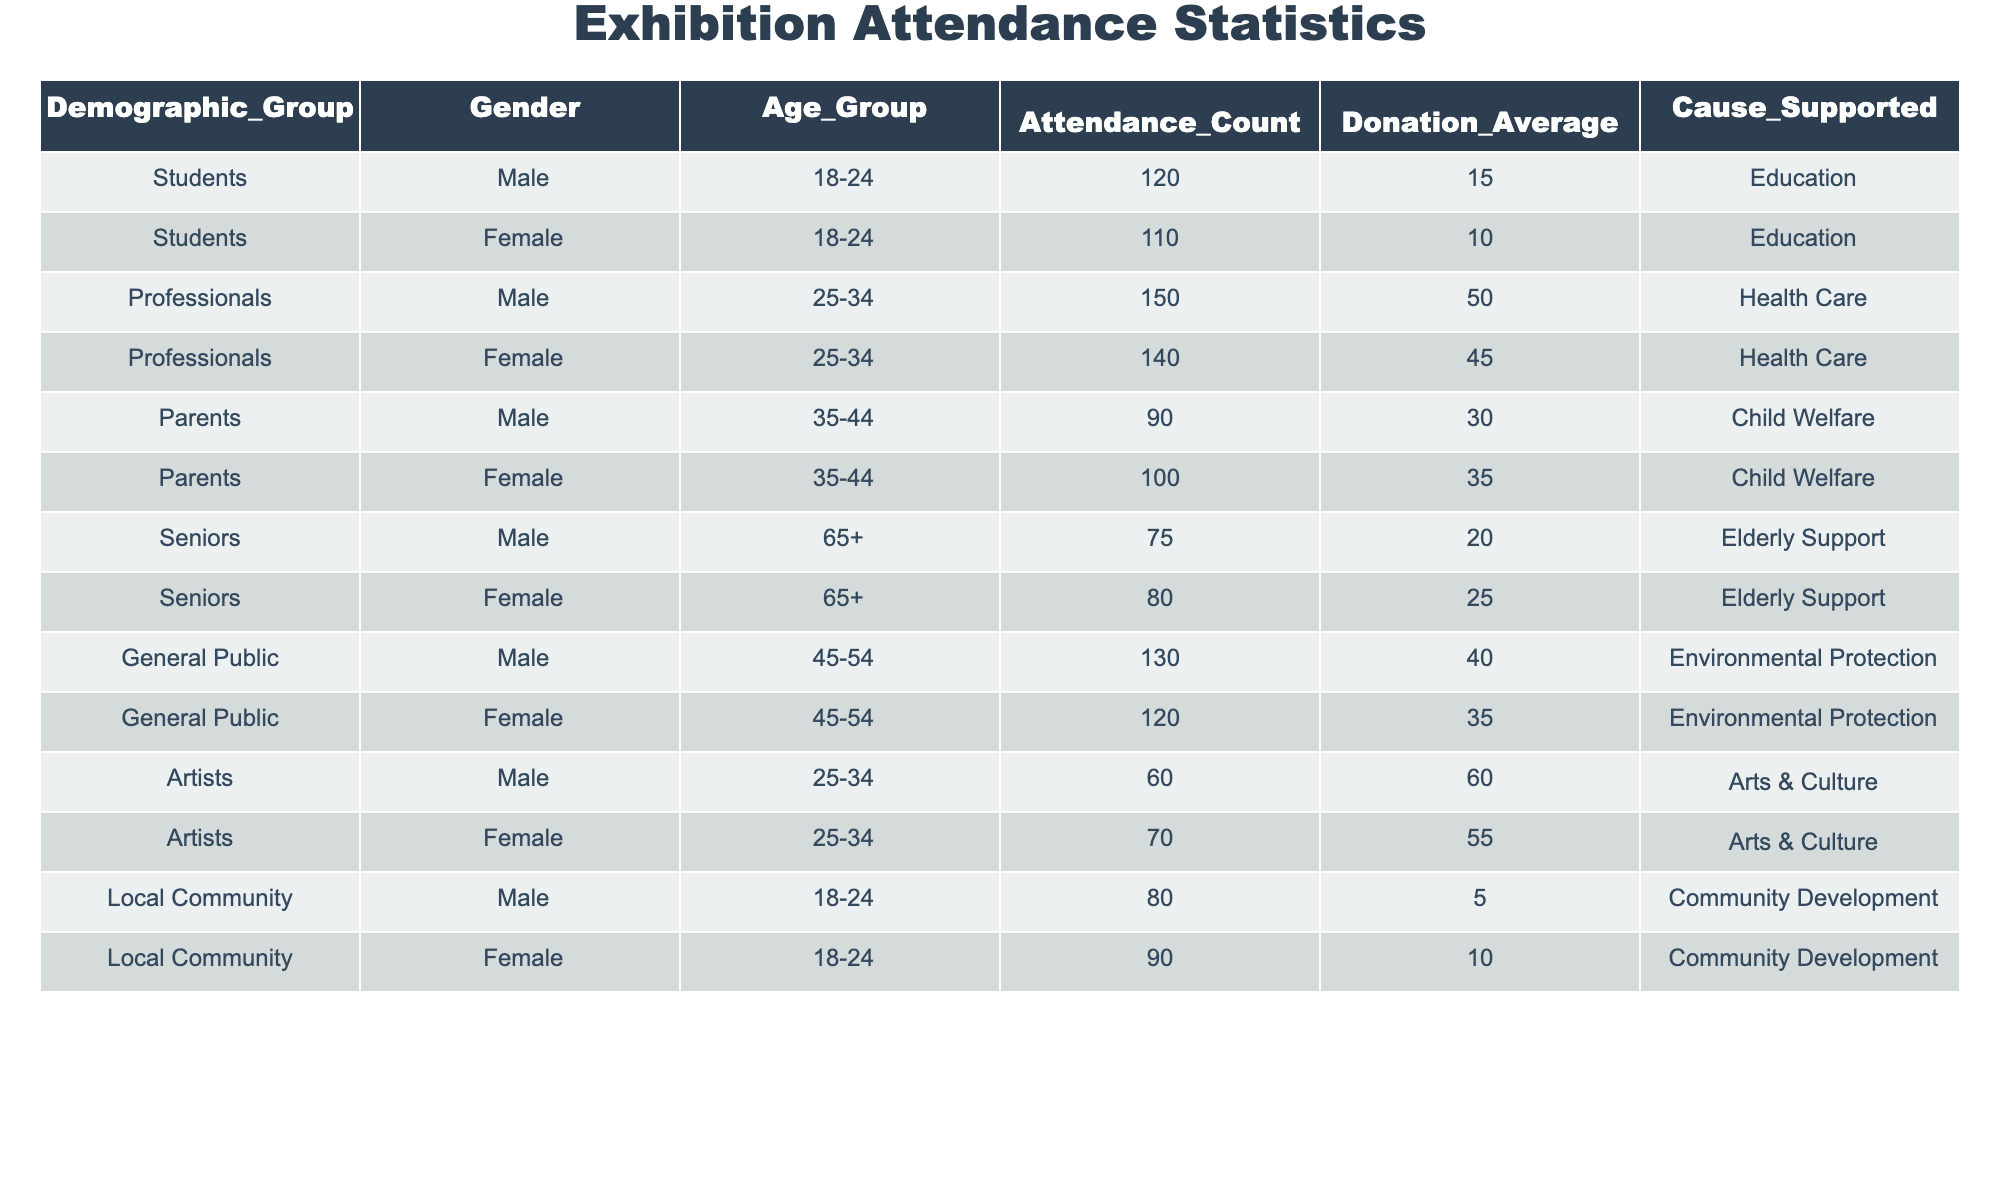What is the attendance count for Female attendees aged 25-34? From the table, the attendance count for Female attendees in the 25-34 age group is directly listed as 140.
Answer: 140 What is the average donation amount for Male Seniors (65+)? The average donation amount for Male Seniors is listed as 20 in the table.
Answer: 20 Which demographic group has the highest total attendance? To find the total attendance, we sum the attendance counts for each demographic group: Students (230), Professionals (290), Parents (190), Seniors (155), General Public (250), Artists (130), Local Community (170); Professionals have the highest total attendance of 290.
Answer: Professionals Is the average donation for Female Students higher than that for Female Parents? The average donation for Female Students is 10, and for Female Parents, it is 35. Since 10 is not greater than 35, the answer is no.
Answer: No What is the difference in average donations between Male Professionals and Male Artists? The average donation for Male Professionals is 50 and for Male Artists is 60. The difference is calculated as 60 - 50 = 10.
Answer: 10 Which demographic group supported Elderly Support with the highest average donation? For the Elderly Support cause, the average donation amounts from Male Seniors is 20 and Female Seniors is 25. Since 25 is higher, Female Seniors have the highest average donation.
Answer: Female Seniors How many total Male attendees are there across all age groups? We sum the attendance counts for all Male attendees: 120 (Students) + 150 (Professionals) + 90 (Parents) + 75 (Seniors) + 130 (General Public) + 60 (Artists) + 80 (Local Community) = 705.
Answer: 705 Do Male and Female Seniors have the same average donation amount? The average donation for Male Seniors is 20 and for Female Seniors is 25. Since these amounts are different, the answer is no.
Answer: No What is the total attendance for all groups under the age group of 18-24? The total attendance for age group 18-24 consists of Male Students (120) + Female Students (110) + Male Local Community (80) + Female Local Community (90) = 400.
Answer: 400 Which demographic group's attendees supported Education cause the most? The total attendance for the Education cause can be calculated: 120 (Male Students) + 110 (Female Students) = 230; thus, Students supported the Education cause the most.
Answer: Students 